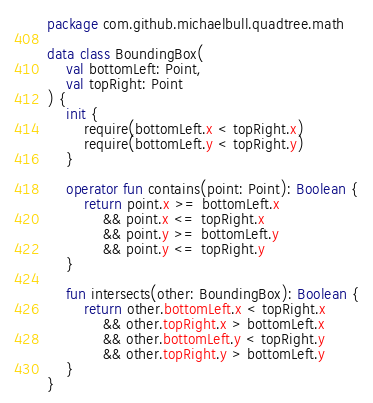<code> <loc_0><loc_0><loc_500><loc_500><_Kotlin_>package com.github.michaelbull.quadtree.math

data class BoundingBox(
    val bottomLeft: Point,
    val topRight: Point
) {
    init {
        require(bottomLeft.x < topRight.x)
        require(bottomLeft.y < topRight.y)
    }

    operator fun contains(point: Point): Boolean {
        return point.x >= bottomLeft.x
            && point.x <= topRight.x
            && point.y >= bottomLeft.y
            && point.y <= topRight.y
    }

    fun intersects(other: BoundingBox): Boolean {
        return other.bottomLeft.x < topRight.x
            && other.topRight.x > bottomLeft.x
            && other.bottomLeft.y < topRight.y
            && other.topRight.y > bottomLeft.y
    }
}
</code> 